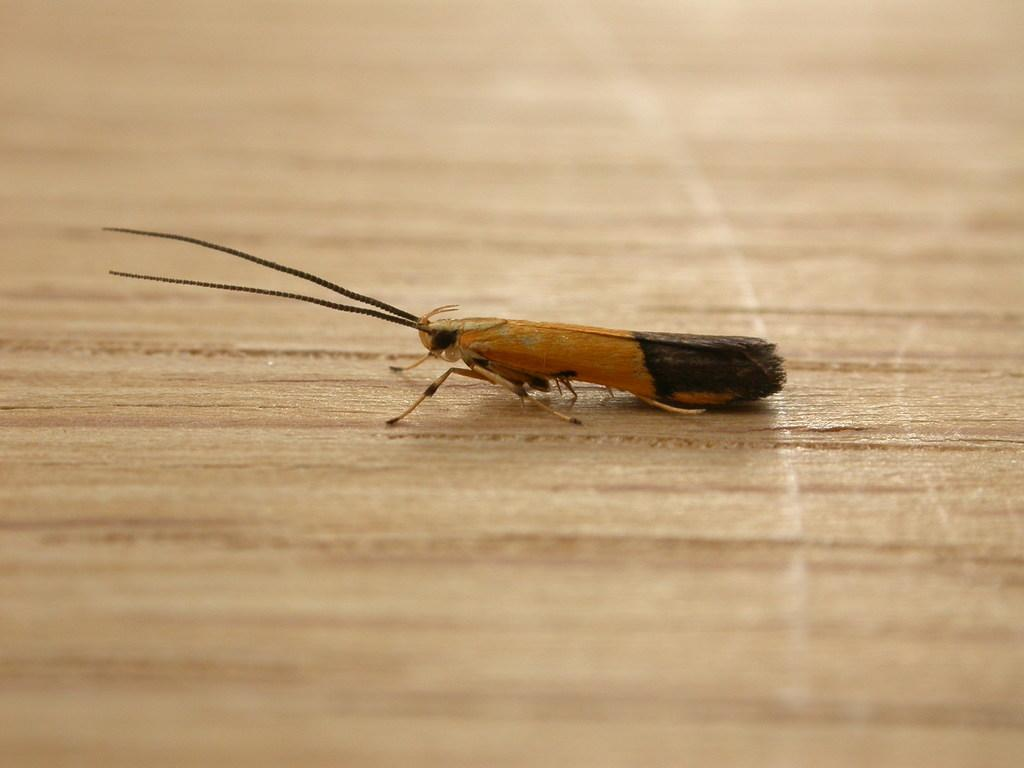What type of creature is present in the image? There is an insect in the picture. Can you describe the colors of the insect? The insect has yellow and black colors. What type of surface is at the bottom of the image? There is a wooden floor at the bottom of the image. What type of quince can be seen hanging from the ceiling in the image? There is no quince present in the image, and no objects are hanging from the ceiling. 